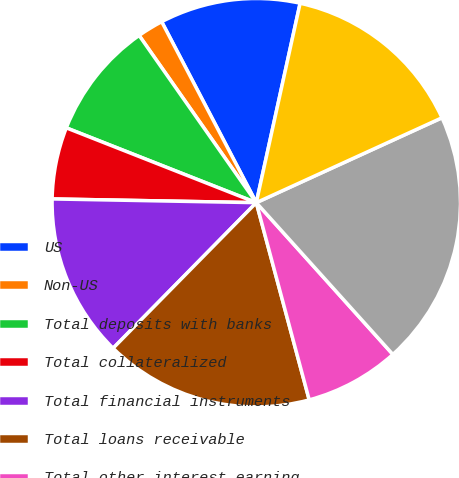Convert chart. <chart><loc_0><loc_0><loc_500><loc_500><pie_chart><fcel>US<fcel>Non-US<fcel>Total deposits with banks<fcel>Total collateralized<fcel>Total financial instruments<fcel>Total loans receivable<fcel>Total other interest-earning<fcel>Change in interest income<fcel>Total interest-bearing<nl><fcel>11.11%<fcel>2.06%<fcel>9.3%<fcel>5.68%<fcel>12.92%<fcel>16.54%<fcel>7.49%<fcel>20.16%<fcel>14.73%<nl></chart> 